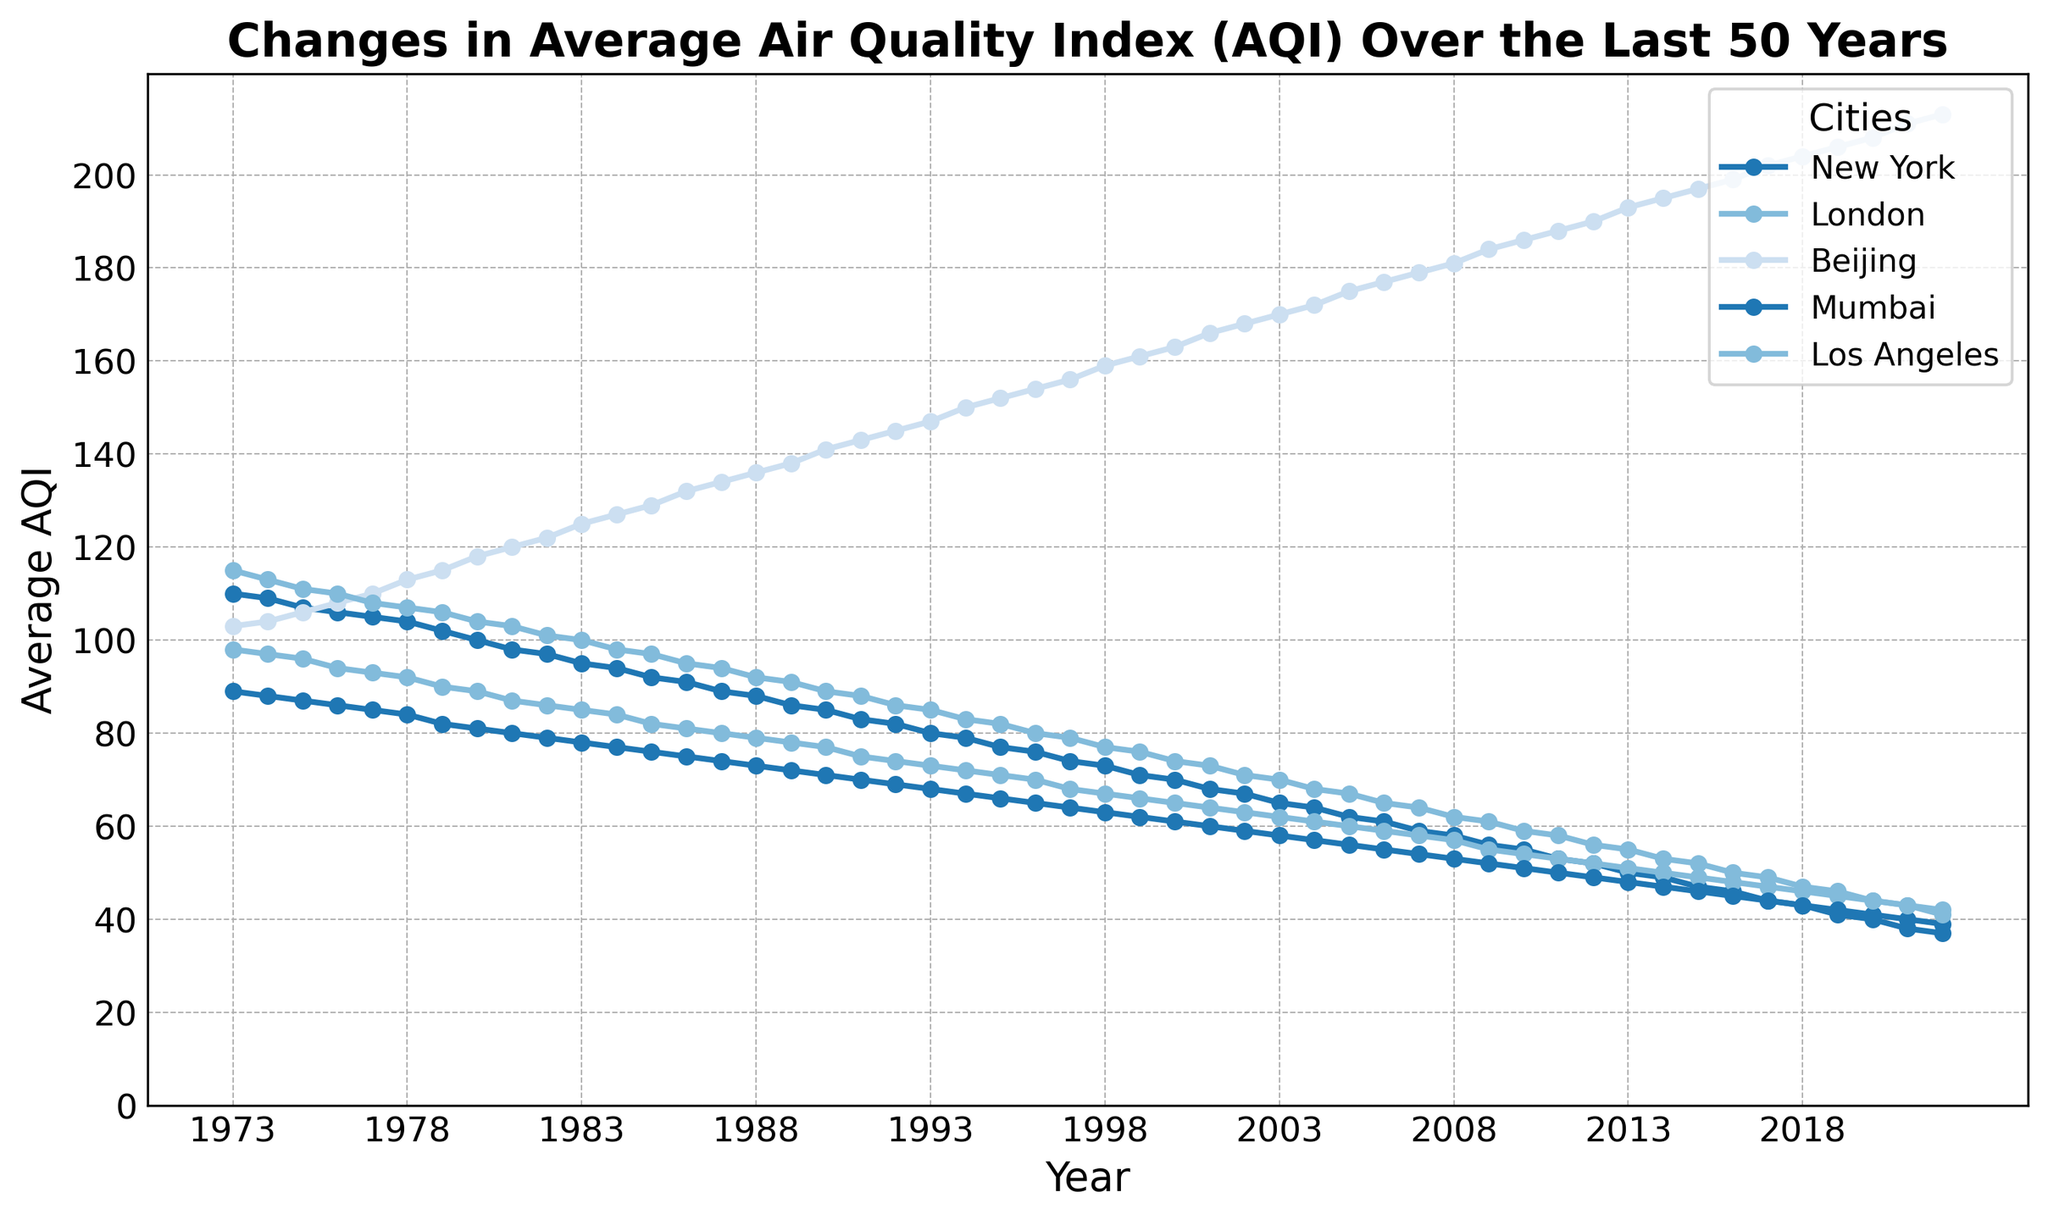What was the AQI value trend for New York over the last 50 years? To answer this, observe the line representing New York. It starts at an AQI of 110 in 1973 and generally decreases to 37 by 2022, showing a downward trend.
Answer: Downward Trend Which city had the largest increase in AQI over the 50-year period? Compare the final AQI in 2022 with the initial AQI in 1973 for each city. Beijing's AQI increased from 103 in 1973 to 213 in 2022, which is the highest increase (110 points).
Answer: Beijing How does the AQI of London in 2022 compare to that in 1973? Look at the AQI values for London in 1973 (98) and 2022 (42). The AQI for London has decreased over the 50 years.
Answer: Decreased Which city had the lowest AQI in 1990? Refer to the values in 1990: New York (85), London (77), Beijing (141), Mumbai (71), Los Angeles (89). London had the lowest AQI of 77.
Answer: London What is the average AQI for Los Angeles over the 50-year period? Sum the AQI values for Los Angeles over all years and divide by 50. Total Los Angeles AQI is (115+113+111+...+41), then average = Total / 50
Answer: 72.5 Between New York and Mumbai, which city saw a greater decrease in AQI from 1973 to 2022? Calculate the difference for each city: New York (110-37) = 73, Mumbai (89-39) = 50. New York saw a greater decrease (73 points).
Answer: New York How many cities had an AQI lower than 50 in 2022? Check the AQI values for 2022: New York (37), London (42), Beijing (213), Mumbai (39), Los Angeles (41). Three cities (New York, London, and Mumbai) had an AQI lower than 50.
Answer: Three At what year did Beijing's AQI cross the 150 mark? Look at Beijing's AQI data and find the first year it exceeds 150. This occurred in 1994 when it reached 150.
Answer: 1994 Which city had the highest AQI in 1985? Compare AQI values for each city in 1985: New York (92), London (82), Beijing (129), Mumbai (76), Los Angeles (97). Beijing had the highest AQI of 129.
Answer: Beijing Did any city's AQI remain fairly constant over the 50 years? Observe the trend lines for each city. While most show clear trends, Los Angeles has a relatively steady gradual decrease without sharp fluctuations.
Answer: Relatively Constant in LA 